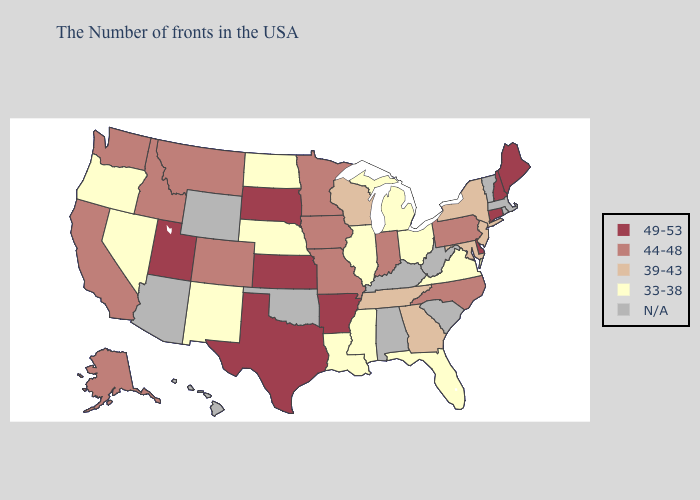What is the value of California?
Quick response, please. 44-48. Name the states that have a value in the range 44-48?
Concise answer only. Pennsylvania, North Carolina, Indiana, Missouri, Minnesota, Iowa, Colorado, Montana, Idaho, California, Washington, Alaska. Does New York have the highest value in the Northeast?
Answer briefly. No. What is the lowest value in the MidWest?
Give a very brief answer. 33-38. What is the value of New York?
Give a very brief answer. 39-43. Does Michigan have the highest value in the USA?
Give a very brief answer. No. Name the states that have a value in the range 44-48?
Write a very short answer. Pennsylvania, North Carolina, Indiana, Missouri, Minnesota, Iowa, Colorado, Montana, Idaho, California, Washington, Alaska. Name the states that have a value in the range 49-53?
Keep it brief. Maine, New Hampshire, Connecticut, Delaware, Arkansas, Kansas, Texas, South Dakota, Utah. Name the states that have a value in the range 44-48?
Short answer required. Pennsylvania, North Carolina, Indiana, Missouri, Minnesota, Iowa, Colorado, Montana, Idaho, California, Washington, Alaska. Which states have the lowest value in the USA?
Be succinct. Virginia, Ohio, Florida, Michigan, Illinois, Mississippi, Louisiana, Nebraska, North Dakota, New Mexico, Nevada, Oregon. Which states have the lowest value in the USA?
Short answer required. Virginia, Ohio, Florida, Michigan, Illinois, Mississippi, Louisiana, Nebraska, North Dakota, New Mexico, Nevada, Oregon. What is the value of Illinois?
Write a very short answer. 33-38. Among the states that border Vermont , does New York have the lowest value?
Be succinct. Yes. What is the lowest value in the Northeast?
Give a very brief answer. 39-43. 